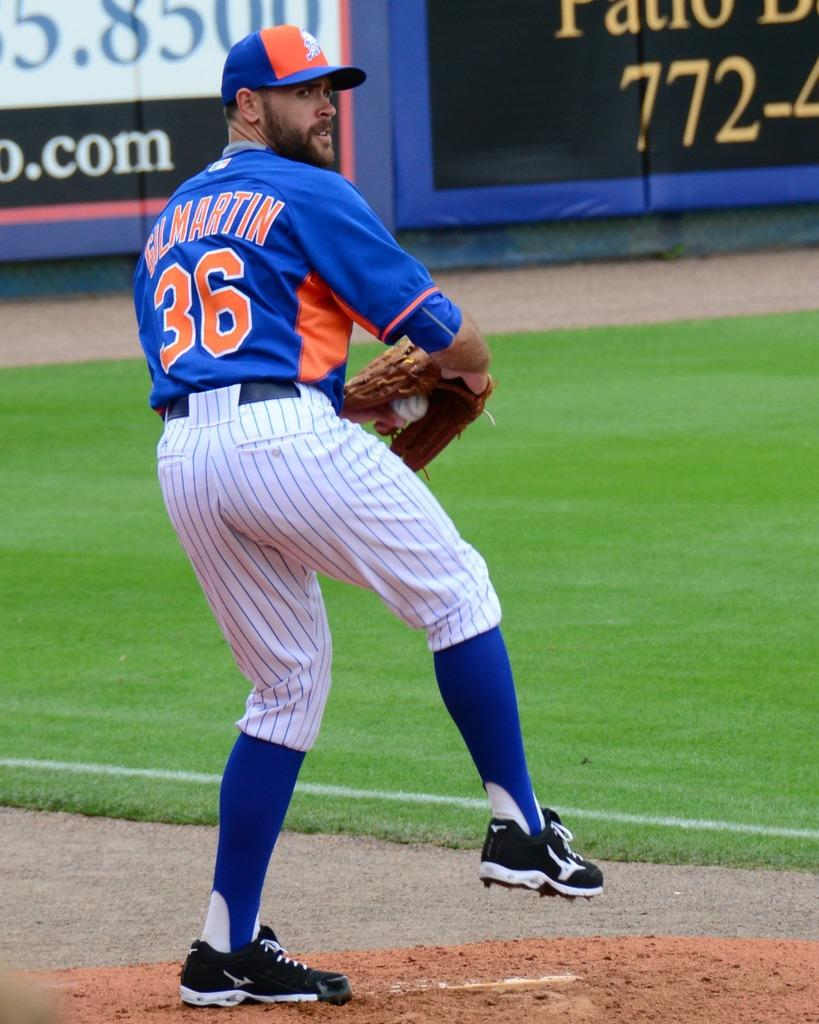<image>
Create a compact narrative representing the image presented. Pitcher number 36 throws a pitch to a batter during a baseball game. 